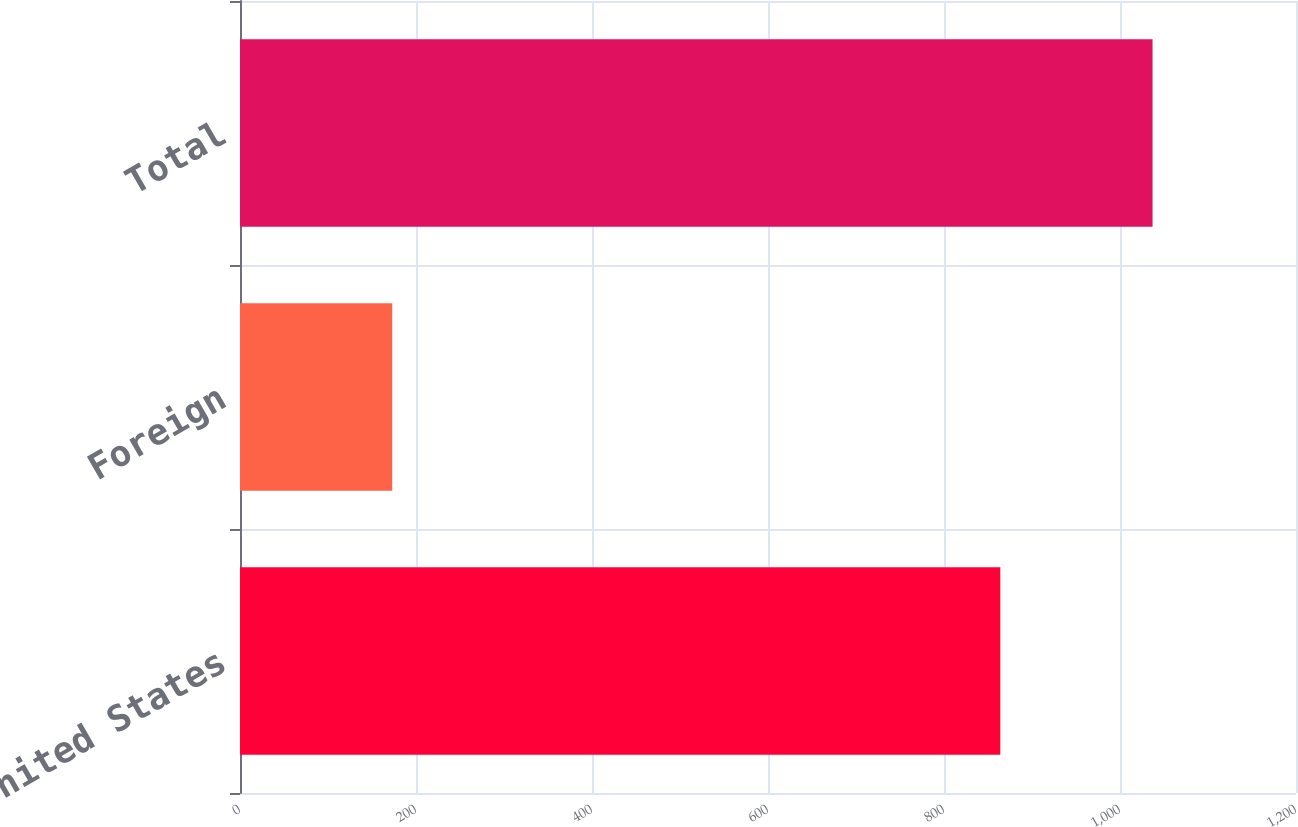Convert chart to OTSL. <chart><loc_0><loc_0><loc_500><loc_500><bar_chart><fcel>United States<fcel>Foreign<fcel>Total<nl><fcel>864<fcel>173<fcel>1037<nl></chart> 